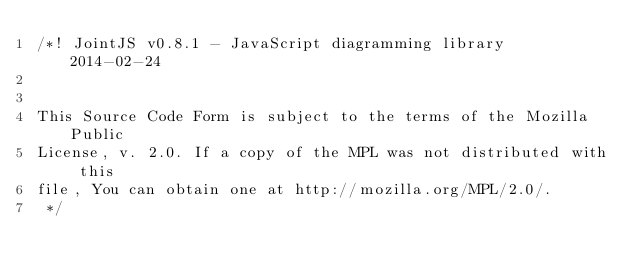<code> <loc_0><loc_0><loc_500><loc_500><_CSS_>/*! JointJS v0.8.1 - JavaScript diagramming library  2014-02-24 


This Source Code Form is subject to the terms of the Mozilla Public
License, v. 2.0. If a copy of the MPL was not distributed with this
file, You can obtain one at http://mozilla.org/MPL/2.0/.
 */
</code> 